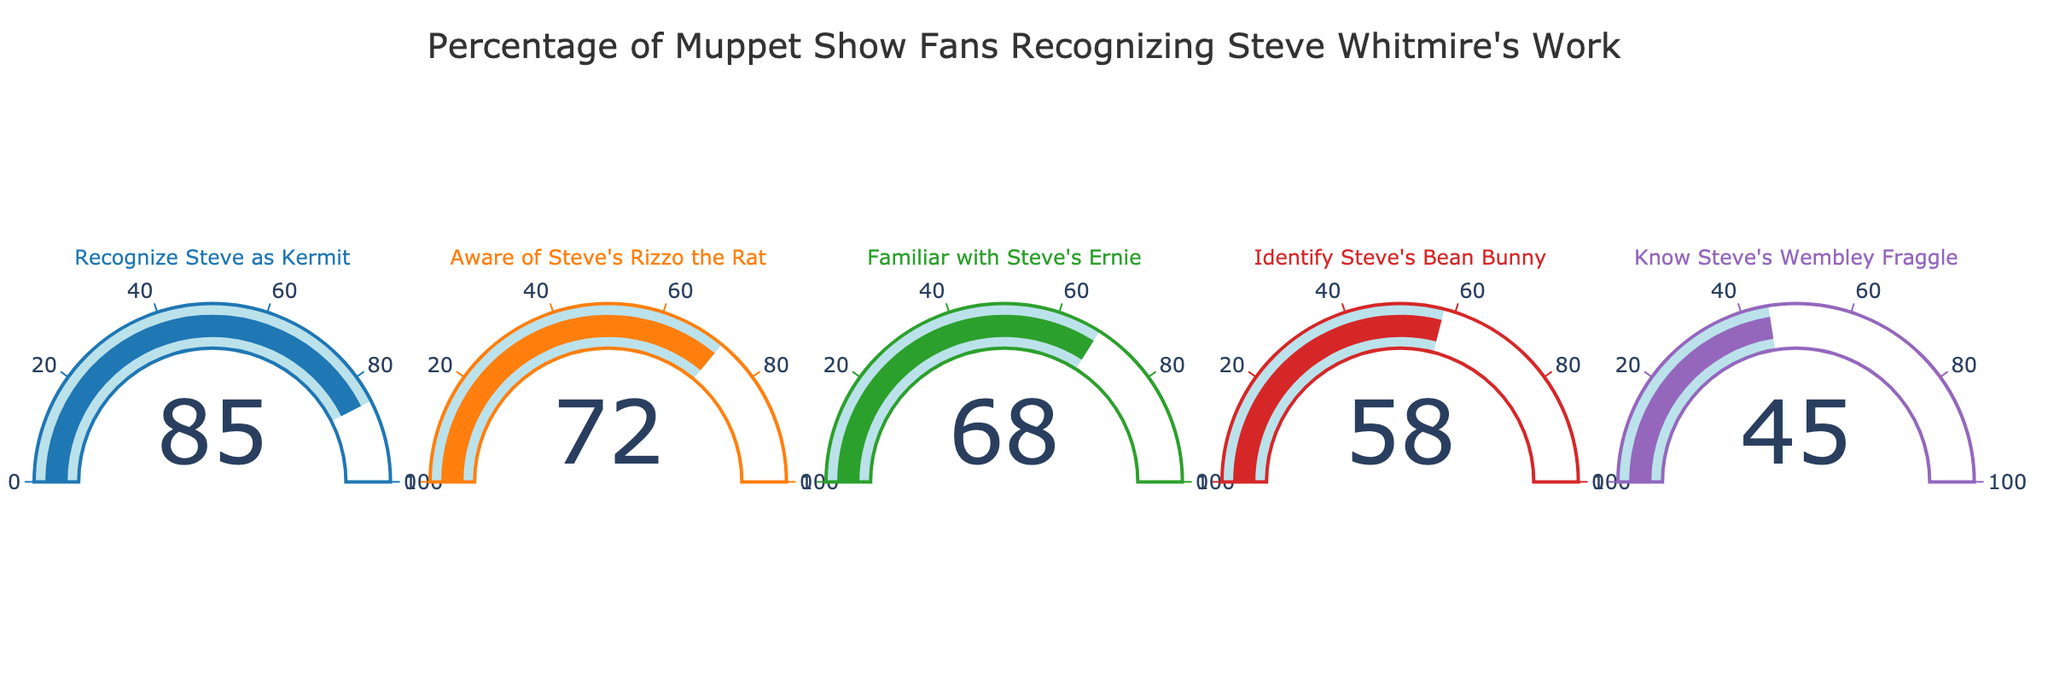What is the title of the chart? The title of the chart is visible at the top of the figure.
Answer: "Percentage of Muppet Show Fans Recognizing Steve Whitmire's Work" How many metrics are shown in the figure? By counting the distinct gauge charts, we can see the number of different metrics displayed.
Answer: 5 Which metric has the highest percentage? Look at the gauge chart with the highest value displayed.
Answer: Recognize Steve as Kermit What is the percentage of fans who identify Steve's Wembley Fraggle? Look at the gauge chart labeled "Wembley Fraggle" to find the percentage value.
Answer: 45% Which metric has the lowest percentage of recognition among fans? Compare the values in each gauge chart and identify the lowest one.
Answer: Know Steve's Wembley Fraggle What is the average recognition percentage of all the metrics combined? Add up the percentages for all metrics and divide by the number of metrics: (85+72+68+58+45)/5.
Answer: 65.6% What is the difference in recognition percentage between Steve's Kermit and Rizzo the Rat? Subtract the percentage of Rizzo the Rat from Kermit: 85 - 72.
Answer: 13% Do more fans recognize Steve's Ernie or his Bean Bunny? Compare the gauge values for Ernie and Bean Bunny.
Answer: Ernie What is the combined recognition percentage for those aware of Steve's work on Kermit and Rizzo the Rat? Sum the percentages of Kermit and Rizzo the Rat: 85 + 72.
Answer: 157% Arrange the metrics in ascending order of recognition percentage. Sort the metrics based on their values from smallest to largest.
Answer: Wembley Fraggle, Bean Bunny, Ernie, Rizzo the Rat, Kermit 